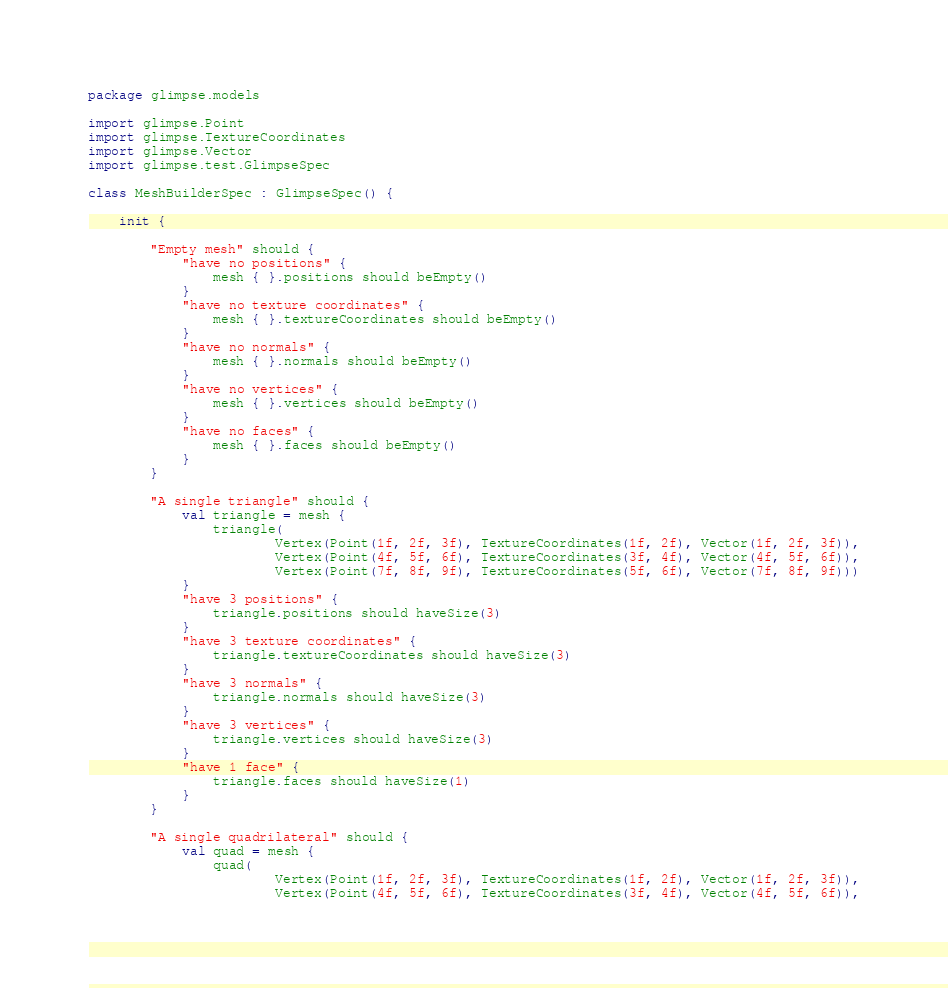Convert code to text. <code><loc_0><loc_0><loc_500><loc_500><_Kotlin_>package glimpse.models

import glimpse.Point
import glimpse.TextureCoordinates
import glimpse.Vector
import glimpse.test.GlimpseSpec

class MeshBuilderSpec : GlimpseSpec() {

	init {

		"Empty mesh" should {
			"have no positions" {
				mesh { }.positions should beEmpty()
			}
			"have no texture coordinates" {
				mesh { }.textureCoordinates should beEmpty()
			}
			"have no normals" {
				mesh { }.normals should beEmpty()
			}
			"have no vertices" {
				mesh { }.vertices should beEmpty()
			}
			"have no faces" {
				mesh { }.faces should beEmpty()
			}
		}

		"A single triangle" should {
			val triangle = mesh {
				triangle(
						Vertex(Point(1f, 2f, 3f), TextureCoordinates(1f, 2f), Vector(1f, 2f, 3f)),
						Vertex(Point(4f, 5f, 6f), TextureCoordinates(3f, 4f), Vector(4f, 5f, 6f)),
						Vertex(Point(7f, 8f, 9f), TextureCoordinates(5f, 6f), Vector(7f, 8f, 9f)))
			}
			"have 3 positions" {
				triangle.positions should haveSize(3)
			}
			"have 3 texture coordinates" {
				triangle.textureCoordinates should haveSize(3)
			}
			"have 3 normals" {
				triangle.normals should haveSize(3)
			}
			"have 3 vertices" {
				triangle.vertices should haveSize(3)
			}
			"have 1 face" {
				triangle.faces should haveSize(1)
			}
		}

		"A single quadrilateral" should {
			val quad = mesh {
				quad(
						Vertex(Point(1f, 2f, 3f), TextureCoordinates(1f, 2f), Vector(1f, 2f, 3f)),
						Vertex(Point(4f, 5f, 6f), TextureCoordinates(3f, 4f), Vector(4f, 5f, 6f)),</code> 